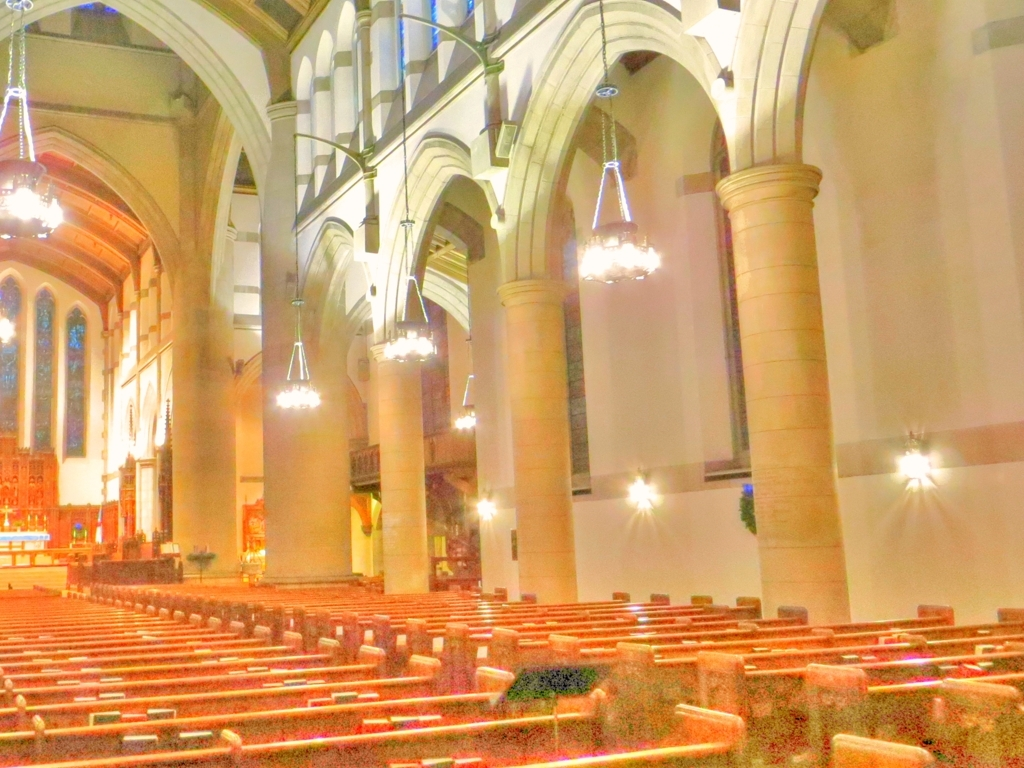Are there any distinctive features in this building that stand out to you? Yes, the patterned floor, the woodwork on the pews, and the stained glass windows are distinctive features. However, due to the overexposure in the photograph, these features are not as prominent as they would be under more balanced lighting conditions. 